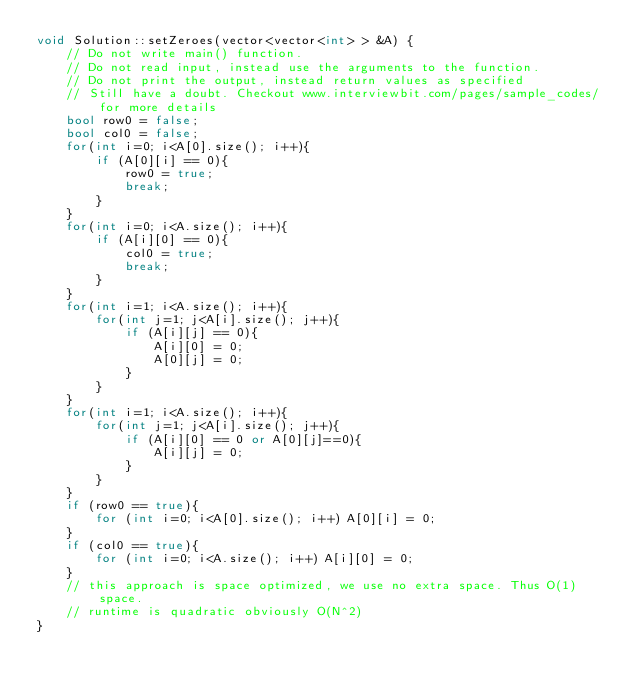<code> <loc_0><loc_0><loc_500><loc_500><_C++_>void Solution::setZeroes(vector<vector<int> > &A) {
    // Do not write main() function.
    // Do not read input, instead use the arguments to the function.
    // Do not print the output, instead return values as specified
    // Still have a doubt. Checkout www.interviewbit.com/pages/sample_codes/ for more details
    bool row0 = false;
    bool col0 = false;
    for(int i=0; i<A[0].size(); i++){
        if (A[0][i] == 0){
            row0 = true;
            break;
        }
    }
    for(int i=0; i<A.size(); i++){
        if (A[i][0] == 0){
            col0 = true;
            break;
        }
    }
    for(int i=1; i<A.size(); i++){
        for(int j=1; j<A[i].size(); j++){
            if (A[i][j] == 0){
                A[i][0] = 0;
                A[0][j] = 0;
            }
        }
    }
    for(int i=1; i<A.size(); i++){
        for(int j=1; j<A[i].size(); j++){
            if (A[i][0] == 0 or A[0][j]==0){
                A[i][j] = 0;
            }
        }
    }
    if (row0 == true){
        for (int i=0; i<A[0].size(); i++) A[0][i] = 0;
    }
    if (col0 == true){
        for (int i=0; i<A.size(); i++) A[i][0] = 0;
    }
    // this approach is space optimized, we use no extra space. Thus O(1) space.
    // runtime is quadratic obviously O(N^2)
}

</code> 